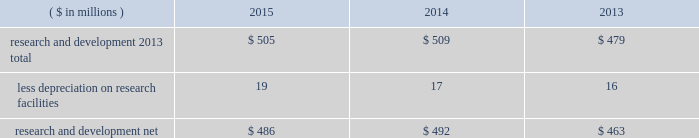38 2015 ppg annual report and form 10-k notes to the consolidated financial statements 1 .
Summary of significant accounting policies principles of consolidation the accompanying consolidated financial statements include the accounts of ppg industries , inc .
( 201cppg 201d or the 201ccompany 201d ) and all subsidiaries , both u.s .
And non-u.s. , that it controls .
Ppg owns more than 50% ( 50 % ) of the voting stock of most of the subsidiaries that it controls .
For those consolidated subsidiaries in which the company 2019s ownership is less than 100% ( 100 % ) , the outside shareholders 2019 interests are shown as noncontrolling interests .
Investments in companies in which ppg owns 20% ( 20 % ) to 50% ( 50 % ) of the voting stock and has the ability to exercise significant influence over operating and financial policies of the investee are accounted for using the equity method of accounting .
As a result , ppg 2019s share of the earnings or losses of such equity affiliates is included in the accompanying consolidated statement of income and ppg 2019s share of these companies 2019 shareholders 2019 equity is included in 201cinvestments 201d in the accompanying consolidated balance sheet .
Transactions between ppg and its subsidiaries are eliminated in consolidation .
Use of estimates in the preparation of financial statements the preparation of financial statements in conformity with u.s .
Generally accepted accounting principles requires management to make estimates and assumptions that affect the reported amounts of assets and liabilities and the disclosure of contingent assets and liabilities at the date of the financial statements , as well as the reported amounts of income and expenses during the reporting period .
Such estimates also include the fair value of assets acquired and liabilities assumed resulting from the allocation of the purchase price related to business combinations consummated .
Actual outcomes could differ from those estimates .
Revenue recognition the company recognizes revenue when the earnings process is complete .
Revenue from sales is recognized by all operating segments when goods are shipped and title to inventory and risk of loss passes to the customer or when services have been rendered .
Shipping and handling costs amounts billed to customers for shipping and handling are reported in 201cnet sales 201d in the accompanying consolidated statement of income .
Shipping and handling costs incurred by the company for the delivery of goods to customers are included in 201ccost of sales , exclusive of depreciation and amortization 201d in the accompanying consolidated statement of income .
Selling , general and administrative costs amounts presented as 201cselling , general and administrative 201d in the accompanying consolidated statement of income are comprised of selling , customer service , distribution and advertising costs , as well as the costs of providing corporate- wide functional support in such areas as finance , law , human resources and planning .
Distribution costs pertain to the movement and storage of finished goods inventory at company- owned and leased warehouses , terminals and other distribution facilities .
Advertising costs advertising costs are expensed as incurred and totaled $ 324 million , $ 297 million and $ 235 million in 2015 , 2014 and 2013 , respectively .
Research and development research and development costs , which consist primarily of employee related costs , are charged to expense as incurred. .
Legal costs legal costs , primarily include costs associated with acquisition and divestiture transactions , general litigation , environmental regulation compliance , patent and trademark protection and other general corporate purposes , are charged to expense as incurred .
Foreign currency translation the functional currency of most significant non-u.s .
Operations is their local currency .
Assets and liabilities of those operations are translated into u.s .
Dollars using year-end exchange rates ; income and expenses are translated using the average exchange rates for the reporting period .
Unrealized foreign currency translation adjustments are deferred in accumulated other comprehensive loss , a separate component of shareholders 2019 equity .
Cash equivalents cash equivalents are highly liquid investments ( valued at cost , which approximates fair value ) acquired with an original maturity of three months or less .
Short-term investments short-term investments are highly liquid , high credit quality investments ( valued at cost plus accrued interest ) that have stated maturities of greater than three months to one year .
The purchases and sales of these investments are classified as investing activities in the consolidated statement of cash flows .
Marketable equity securities the company 2019s investment in marketable equity securities is recorded at fair market value and reported in 201cother current assets 201d and 201cinvestments 201d in the accompanying consolidated balance sheet with changes in fair market value recorded in income for those securities designated as trading securities and in other comprehensive income , net of tax , for those designated as available for sale securities. .
What were average advertising costs for the three year period , in millions? 
Computations: (((324 + 297) + 235) / 3)
Answer: 285.33333. 